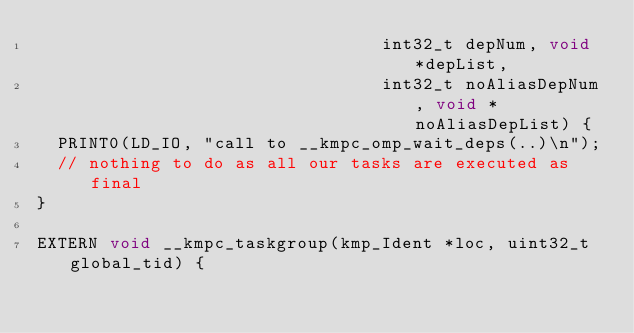Convert code to text. <code><loc_0><loc_0><loc_500><loc_500><_Cuda_>                                 int32_t depNum, void *depList,
                                 int32_t noAliasDepNum, void *noAliasDepList) {
  PRINT0(LD_IO, "call to __kmpc_omp_wait_deps(..)\n");
  // nothing to do as all our tasks are executed as final
}

EXTERN void __kmpc_taskgroup(kmp_Ident *loc, uint32_t global_tid) {</code> 